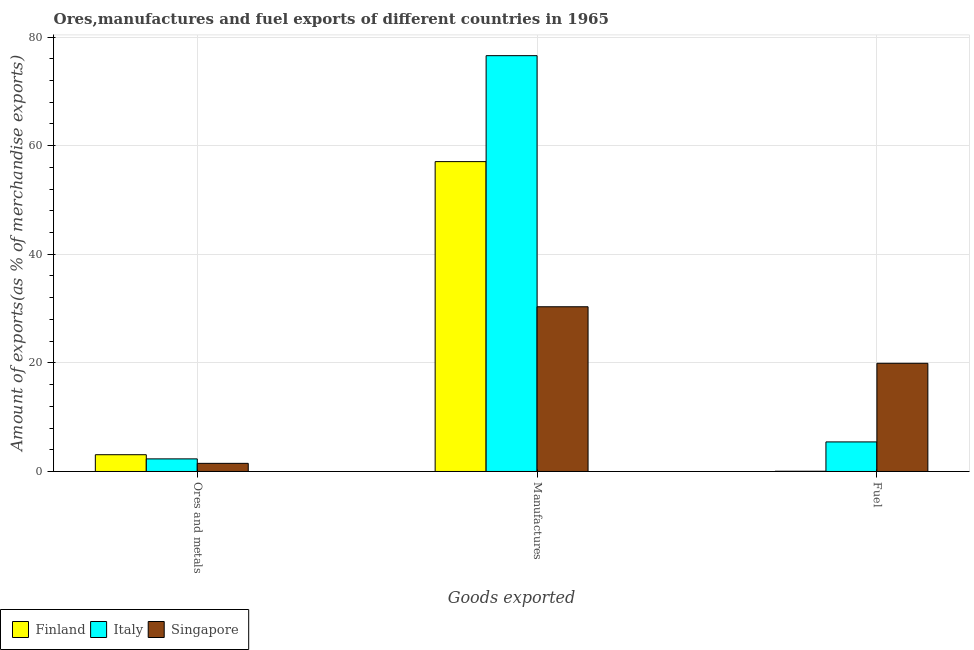How many different coloured bars are there?
Your response must be concise. 3. How many groups of bars are there?
Make the answer very short. 3. How many bars are there on the 2nd tick from the left?
Your answer should be very brief. 3. How many bars are there on the 1st tick from the right?
Offer a terse response. 3. What is the label of the 1st group of bars from the left?
Give a very brief answer. Ores and metals. What is the percentage of ores and metals exports in Italy?
Offer a terse response. 2.32. Across all countries, what is the maximum percentage of ores and metals exports?
Your answer should be very brief. 3.09. Across all countries, what is the minimum percentage of fuel exports?
Make the answer very short. 0.04. In which country was the percentage of ores and metals exports maximum?
Provide a short and direct response. Finland. What is the total percentage of fuel exports in the graph?
Your answer should be very brief. 25.41. What is the difference between the percentage of ores and metals exports in Italy and that in Finland?
Your answer should be compact. -0.77. What is the difference between the percentage of fuel exports in Finland and the percentage of manufactures exports in Singapore?
Keep it short and to the point. -30.29. What is the average percentage of manufactures exports per country?
Keep it short and to the point. 54.65. What is the difference between the percentage of manufactures exports and percentage of fuel exports in Singapore?
Your answer should be very brief. 10.41. What is the ratio of the percentage of ores and metals exports in Singapore to that in Finland?
Offer a very short reply. 0.48. What is the difference between the highest and the second highest percentage of ores and metals exports?
Offer a terse response. 0.77. What is the difference between the highest and the lowest percentage of manufactures exports?
Your response must be concise. 46.24. What does the 3rd bar from the right in Fuel represents?
Keep it short and to the point. Finland. Are all the bars in the graph horizontal?
Your answer should be compact. No. What is the difference between two consecutive major ticks on the Y-axis?
Give a very brief answer. 20. How many legend labels are there?
Make the answer very short. 3. What is the title of the graph?
Keep it short and to the point. Ores,manufactures and fuel exports of different countries in 1965. What is the label or title of the X-axis?
Provide a succinct answer. Goods exported. What is the label or title of the Y-axis?
Give a very brief answer. Amount of exports(as % of merchandise exports). What is the Amount of exports(as % of merchandise exports) of Finland in Ores and metals?
Offer a very short reply. 3.09. What is the Amount of exports(as % of merchandise exports) in Italy in Ores and metals?
Offer a terse response. 2.32. What is the Amount of exports(as % of merchandise exports) in Singapore in Ores and metals?
Your answer should be compact. 1.5. What is the Amount of exports(as % of merchandise exports) of Finland in Manufactures?
Your answer should be very brief. 57.06. What is the Amount of exports(as % of merchandise exports) of Italy in Manufactures?
Your answer should be compact. 76.57. What is the Amount of exports(as % of merchandise exports) in Singapore in Manufactures?
Provide a short and direct response. 30.33. What is the Amount of exports(as % of merchandise exports) of Finland in Fuel?
Make the answer very short. 0.04. What is the Amount of exports(as % of merchandise exports) in Italy in Fuel?
Offer a very short reply. 5.45. What is the Amount of exports(as % of merchandise exports) in Singapore in Fuel?
Provide a short and direct response. 19.92. Across all Goods exported, what is the maximum Amount of exports(as % of merchandise exports) of Finland?
Ensure brevity in your answer.  57.06. Across all Goods exported, what is the maximum Amount of exports(as % of merchandise exports) of Italy?
Your answer should be compact. 76.57. Across all Goods exported, what is the maximum Amount of exports(as % of merchandise exports) in Singapore?
Give a very brief answer. 30.33. Across all Goods exported, what is the minimum Amount of exports(as % of merchandise exports) in Finland?
Make the answer very short. 0.04. Across all Goods exported, what is the minimum Amount of exports(as % of merchandise exports) of Italy?
Offer a very short reply. 2.32. Across all Goods exported, what is the minimum Amount of exports(as % of merchandise exports) in Singapore?
Your response must be concise. 1.5. What is the total Amount of exports(as % of merchandise exports) in Finland in the graph?
Your response must be concise. 60.19. What is the total Amount of exports(as % of merchandise exports) in Italy in the graph?
Provide a succinct answer. 84.33. What is the total Amount of exports(as % of merchandise exports) in Singapore in the graph?
Your answer should be very brief. 51.75. What is the difference between the Amount of exports(as % of merchandise exports) of Finland in Ores and metals and that in Manufactures?
Offer a very short reply. -53.97. What is the difference between the Amount of exports(as % of merchandise exports) in Italy in Ores and metals and that in Manufactures?
Make the answer very short. -74.25. What is the difference between the Amount of exports(as % of merchandise exports) in Singapore in Ores and metals and that in Manufactures?
Ensure brevity in your answer.  -28.83. What is the difference between the Amount of exports(as % of merchandise exports) in Finland in Ores and metals and that in Fuel?
Your answer should be very brief. 3.05. What is the difference between the Amount of exports(as % of merchandise exports) in Italy in Ores and metals and that in Fuel?
Offer a terse response. -3.13. What is the difference between the Amount of exports(as % of merchandise exports) of Singapore in Ores and metals and that in Fuel?
Make the answer very short. -18.42. What is the difference between the Amount of exports(as % of merchandise exports) of Finland in Manufactures and that in Fuel?
Provide a short and direct response. 57.01. What is the difference between the Amount of exports(as % of merchandise exports) of Italy in Manufactures and that in Fuel?
Keep it short and to the point. 71.12. What is the difference between the Amount of exports(as % of merchandise exports) of Singapore in Manufactures and that in Fuel?
Your answer should be compact. 10.41. What is the difference between the Amount of exports(as % of merchandise exports) in Finland in Ores and metals and the Amount of exports(as % of merchandise exports) in Italy in Manufactures?
Make the answer very short. -73.48. What is the difference between the Amount of exports(as % of merchandise exports) of Finland in Ores and metals and the Amount of exports(as % of merchandise exports) of Singapore in Manufactures?
Your response must be concise. -27.24. What is the difference between the Amount of exports(as % of merchandise exports) in Italy in Ores and metals and the Amount of exports(as % of merchandise exports) in Singapore in Manufactures?
Offer a very short reply. -28.01. What is the difference between the Amount of exports(as % of merchandise exports) of Finland in Ores and metals and the Amount of exports(as % of merchandise exports) of Italy in Fuel?
Offer a terse response. -2.36. What is the difference between the Amount of exports(as % of merchandise exports) of Finland in Ores and metals and the Amount of exports(as % of merchandise exports) of Singapore in Fuel?
Your answer should be compact. -16.83. What is the difference between the Amount of exports(as % of merchandise exports) of Italy in Ores and metals and the Amount of exports(as % of merchandise exports) of Singapore in Fuel?
Provide a succinct answer. -17.6. What is the difference between the Amount of exports(as % of merchandise exports) of Finland in Manufactures and the Amount of exports(as % of merchandise exports) of Italy in Fuel?
Your answer should be very brief. 51.61. What is the difference between the Amount of exports(as % of merchandise exports) of Finland in Manufactures and the Amount of exports(as % of merchandise exports) of Singapore in Fuel?
Provide a short and direct response. 37.14. What is the difference between the Amount of exports(as % of merchandise exports) of Italy in Manufactures and the Amount of exports(as % of merchandise exports) of Singapore in Fuel?
Your answer should be compact. 56.65. What is the average Amount of exports(as % of merchandise exports) in Finland per Goods exported?
Keep it short and to the point. 20.06. What is the average Amount of exports(as % of merchandise exports) of Italy per Goods exported?
Keep it short and to the point. 28.11. What is the average Amount of exports(as % of merchandise exports) of Singapore per Goods exported?
Provide a succinct answer. 17.25. What is the difference between the Amount of exports(as % of merchandise exports) of Finland and Amount of exports(as % of merchandise exports) of Italy in Ores and metals?
Keep it short and to the point. 0.77. What is the difference between the Amount of exports(as % of merchandise exports) of Finland and Amount of exports(as % of merchandise exports) of Singapore in Ores and metals?
Provide a short and direct response. 1.59. What is the difference between the Amount of exports(as % of merchandise exports) of Italy and Amount of exports(as % of merchandise exports) of Singapore in Ores and metals?
Make the answer very short. 0.82. What is the difference between the Amount of exports(as % of merchandise exports) of Finland and Amount of exports(as % of merchandise exports) of Italy in Manufactures?
Your response must be concise. -19.51. What is the difference between the Amount of exports(as % of merchandise exports) in Finland and Amount of exports(as % of merchandise exports) in Singapore in Manufactures?
Ensure brevity in your answer.  26.73. What is the difference between the Amount of exports(as % of merchandise exports) of Italy and Amount of exports(as % of merchandise exports) of Singapore in Manufactures?
Keep it short and to the point. 46.23. What is the difference between the Amount of exports(as % of merchandise exports) of Finland and Amount of exports(as % of merchandise exports) of Italy in Fuel?
Ensure brevity in your answer.  -5.4. What is the difference between the Amount of exports(as % of merchandise exports) of Finland and Amount of exports(as % of merchandise exports) of Singapore in Fuel?
Provide a succinct answer. -19.88. What is the difference between the Amount of exports(as % of merchandise exports) in Italy and Amount of exports(as % of merchandise exports) in Singapore in Fuel?
Keep it short and to the point. -14.48. What is the ratio of the Amount of exports(as % of merchandise exports) in Finland in Ores and metals to that in Manufactures?
Your answer should be very brief. 0.05. What is the ratio of the Amount of exports(as % of merchandise exports) in Italy in Ores and metals to that in Manufactures?
Your answer should be very brief. 0.03. What is the ratio of the Amount of exports(as % of merchandise exports) in Singapore in Ores and metals to that in Manufactures?
Your response must be concise. 0.05. What is the ratio of the Amount of exports(as % of merchandise exports) of Finland in Ores and metals to that in Fuel?
Your response must be concise. 71.71. What is the ratio of the Amount of exports(as % of merchandise exports) in Italy in Ores and metals to that in Fuel?
Give a very brief answer. 0.43. What is the ratio of the Amount of exports(as % of merchandise exports) in Singapore in Ores and metals to that in Fuel?
Your answer should be very brief. 0.08. What is the ratio of the Amount of exports(as % of merchandise exports) of Finland in Manufactures to that in Fuel?
Give a very brief answer. 1324.27. What is the ratio of the Amount of exports(as % of merchandise exports) of Italy in Manufactures to that in Fuel?
Ensure brevity in your answer.  14.06. What is the ratio of the Amount of exports(as % of merchandise exports) of Singapore in Manufactures to that in Fuel?
Offer a very short reply. 1.52. What is the difference between the highest and the second highest Amount of exports(as % of merchandise exports) in Finland?
Offer a very short reply. 53.97. What is the difference between the highest and the second highest Amount of exports(as % of merchandise exports) in Italy?
Your response must be concise. 71.12. What is the difference between the highest and the second highest Amount of exports(as % of merchandise exports) in Singapore?
Offer a very short reply. 10.41. What is the difference between the highest and the lowest Amount of exports(as % of merchandise exports) in Finland?
Offer a very short reply. 57.01. What is the difference between the highest and the lowest Amount of exports(as % of merchandise exports) in Italy?
Offer a very short reply. 74.25. What is the difference between the highest and the lowest Amount of exports(as % of merchandise exports) in Singapore?
Make the answer very short. 28.83. 